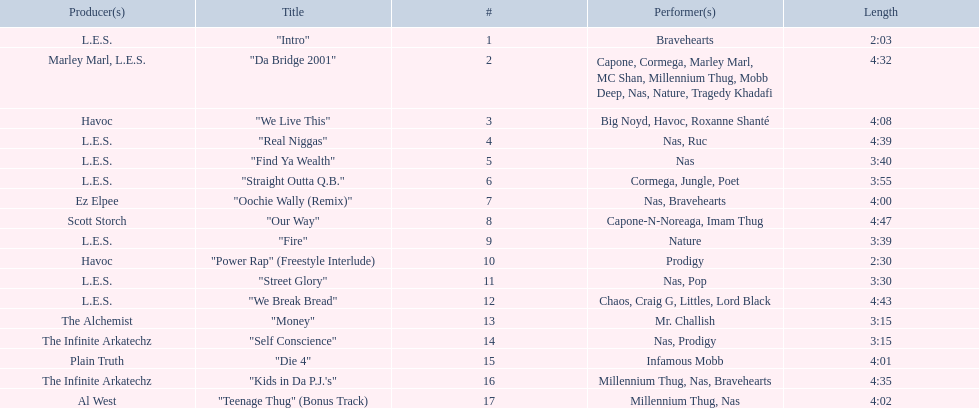Can you give me this table as a dict? {'header': ['Producer(s)', 'Title', '#', 'Performer(s)', 'Length'], 'rows': [['L.E.S.', '"Intro"', '1', 'Bravehearts', '2:03'], ['Marley Marl, L.E.S.', '"Da Bridge 2001"', '2', 'Capone, Cormega, Marley Marl, MC Shan, Millennium Thug, Mobb Deep, Nas, Nature, Tragedy Khadafi', '4:32'], ['Havoc', '"We Live This"', '3', 'Big Noyd, Havoc, Roxanne Shanté', '4:08'], ['L.E.S.', '"Real Niggas"', '4', 'Nas, Ruc', '4:39'], ['L.E.S.', '"Find Ya Wealth"', '5', 'Nas', '3:40'], ['L.E.S.', '"Straight Outta Q.B."', '6', 'Cormega, Jungle, Poet', '3:55'], ['Ez Elpee', '"Oochie Wally (Remix)"', '7', 'Nas, Bravehearts', '4:00'], ['Scott Storch', '"Our Way"', '8', 'Capone-N-Noreaga, Imam Thug', '4:47'], ['L.E.S.', '"Fire"', '9', 'Nature', '3:39'], ['Havoc', '"Power Rap" (Freestyle Interlude)', '10', 'Prodigy', '2:30'], ['L.E.S.', '"Street Glory"', '11', 'Nas, Pop', '3:30'], ['L.E.S.', '"We Break Bread"', '12', 'Chaos, Craig G, Littles, Lord Black', '4:43'], ['The Alchemist', '"Money"', '13', 'Mr. Challish', '3:15'], ['The Infinite Arkatechz', '"Self Conscience"', '14', 'Nas, Prodigy', '3:15'], ['Plain Truth', '"Die 4"', '15', 'Infamous Mobb', '4:01'], ['The Infinite Arkatechz', '"Kids in Da P.J.\'s"', '16', 'Millennium Thug, Nas, Bravehearts', '4:35'], ['Al West', '"Teenage Thug" (Bonus Track)', '17', 'Millennium Thug, Nas', '4:02']]} How long is the longest track listed? 4:47. 